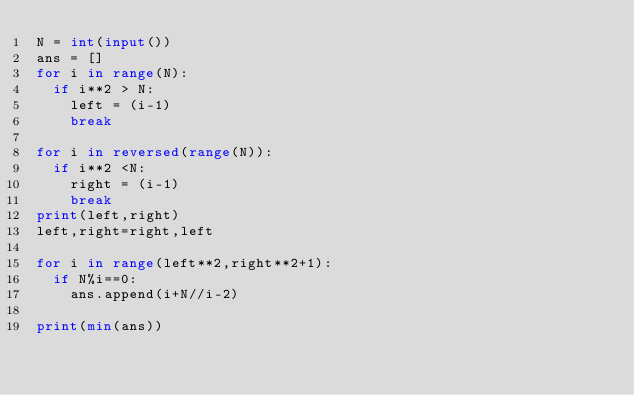Convert code to text. <code><loc_0><loc_0><loc_500><loc_500><_Python_>N = int(input())
ans = []
for i in range(N):
	if i**2 > N:
		left = (i-1)
		break

for i in reversed(range(N)):
	if i**2 <N:
		right = (i-1)
		break
print(left,right)
left,right=right,left

for i in range(left**2,right**2+1):
	if N%i==0:
		ans.append(i+N//i-2)

print(min(ans))</code> 